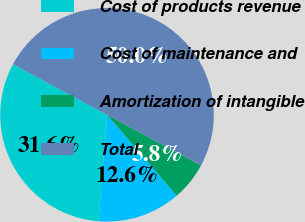<chart> <loc_0><loc_0><loc_500><loc_500><pie_chart><fcel>Cost of products revenue<fcel>Cost of maintenance and<fcel>Amortization of intangible<fcel>Total<nl><fcel>31.58%<fcel>12.6%<fcel>5.82%<fcel>50.0%<nl></chart> 